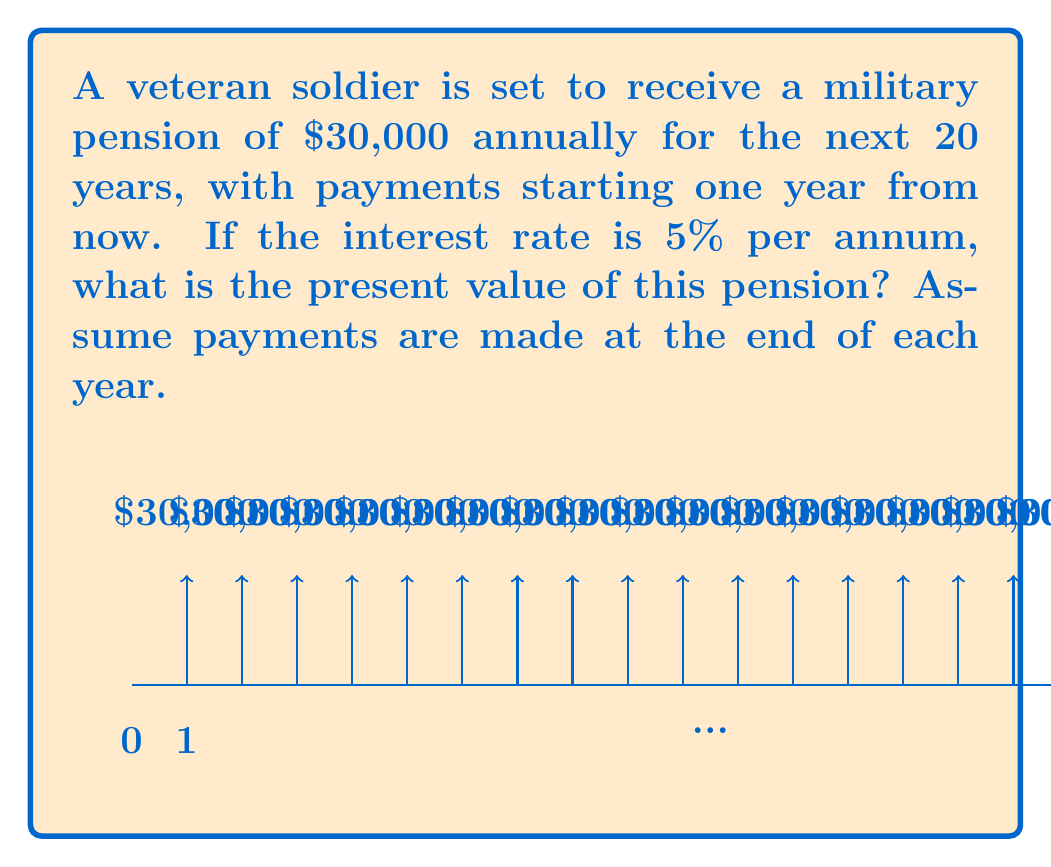What is the answer to this math problem? To solve this problem, we need to use the present value of an annuity formula:

$$PV = \frac{PMT}{r} \left[1 - \frac{1}{(1+r)^n}\right]$$

Where:
$PV$ = Present Value
$PMT$ = Payment amount
$r$ = Interest rate per period
$n$ = Number of periods

Given:
$PMT = \$30,000$
$r = 5\% = 0.05$
$n = 20$ years

Step 1: Plug the values into the formula
$$PV = \frac{30,000}{0.05} \left[1 - \frac{1}{(1+0.05)^{20}}\right]$$

Step 2: Simplify the expression inside the brackets
$$PV = 600,000 \left[1 - \frac{1}{1.05^{20}}\right]$$

Step 3: Calculate $1.05^{20}$
$1.05^{20} \approx 2.6533$

Step 4: Complete the calculation
$$PV = 600,000 \left[1 - \frac{1}{2.6533}\right] \approx 600,000 \times 0.6232 \approx 373,920$$

Therefore, the present value of the military pension is approximately $373,920.
Answer: $373,920 